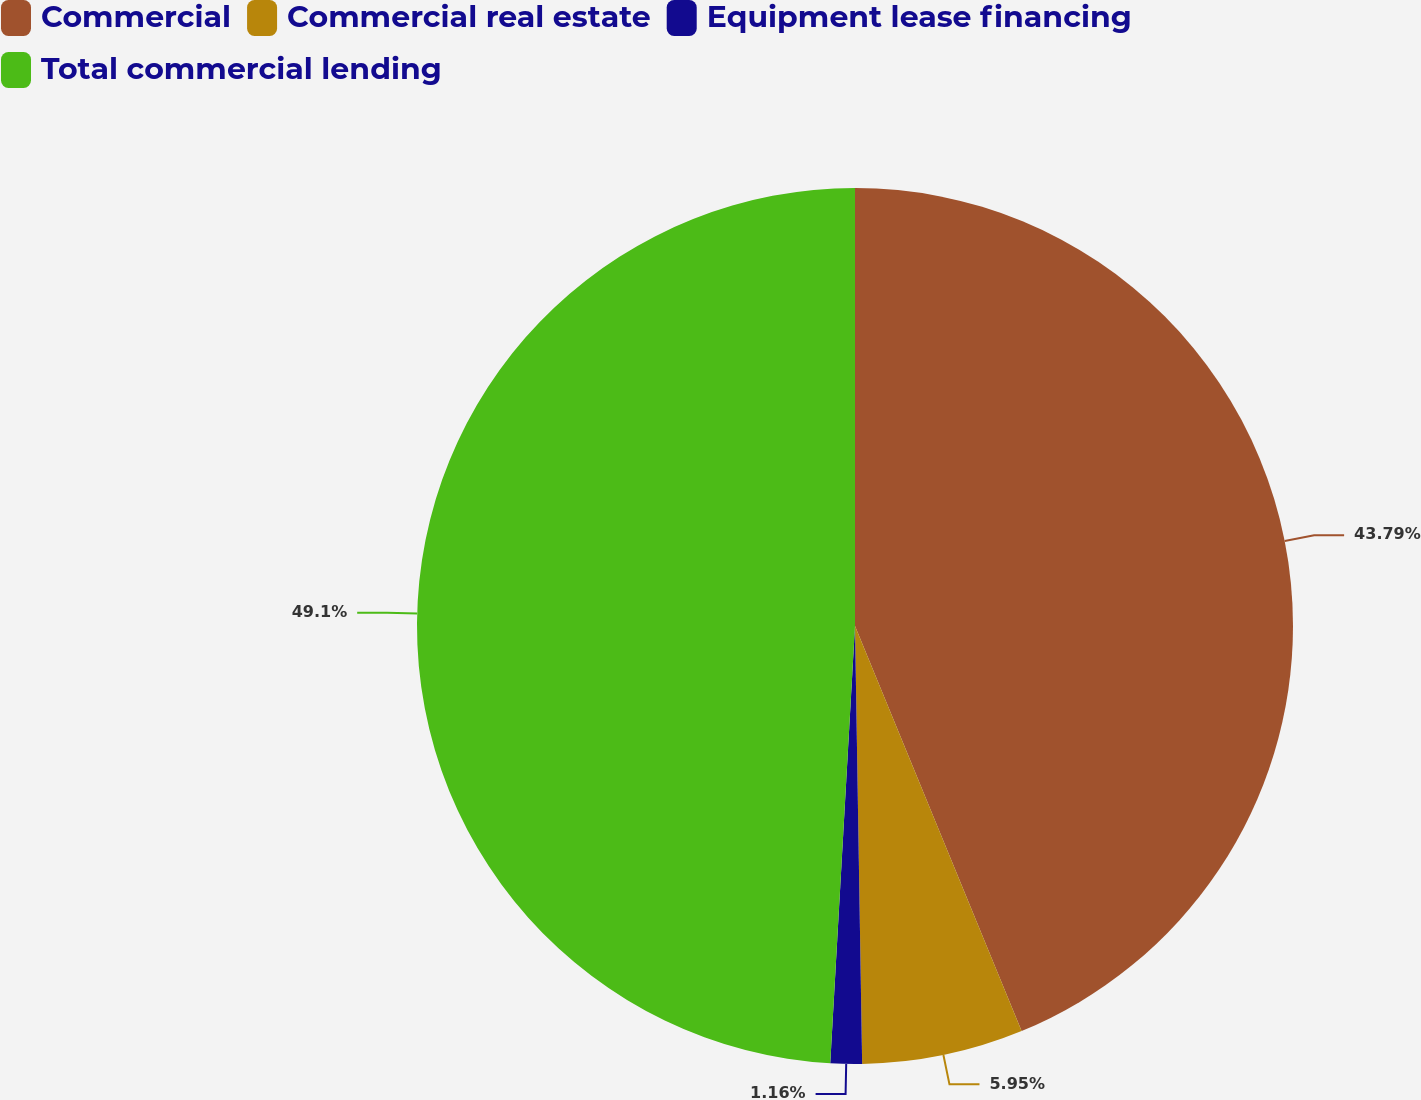Convert chart to OTSL. <chart><loc_0><loc_0><loc_500><loc_500><pie_chart><fcel>Commercial<fcel>Commercial real estate<fcel>Equipment lease financing<fcel>Total commercial lending<nl><fcel>43.79%<fcel>5.95%<fcel>1.16%<fcel>49.1%<nl></chart> 